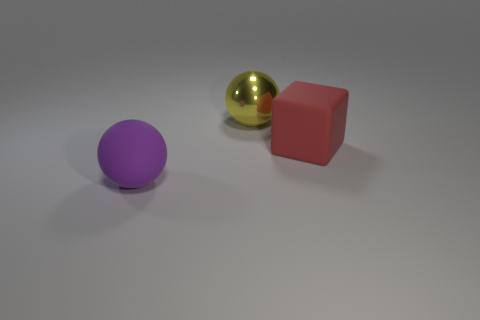Are there any other things that have the same material as the big yellow object?
Give a very brief answer. No. What number of cylinders are matte things or large red rubber objects?
Make the answer very short. 0. Are there fewer shiny spheres in front of the large block than big red rubber objects?
Keep it short and to the point. Yes. The large object that is both right of the big purple thing and to the left of the big red rubber thing is what color?
Your answer should be compact. Yellow. What number of other things are there of the same shape as the red rubber thing?
Offer a terse response. 0. Are there fewer purple rubber balls that are behind the red block than matte spheres that are right of the big purple rubber ball?
Ensure brevity in your answer.  No. Is the large purple object made of the same material as the big ball that is behind the large rubber block?
Make the answer very short. No. Is the number of spheres greater than the number of large red matte objects?
Make the answer very short. Yes. There is a big object that is to the left of the big sphere that is behind the object that is to the left of the metal sphere; what is its shape?
Provide a short and direct response. Sphere. Are the large ball that is behind the big purple ball and the object in front of the big rubber cube made of the same material?
Your answer should be compact. No. 